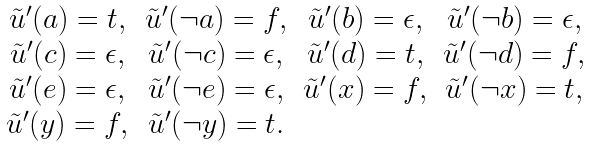Convert formula to latex. <formula><loc_0><loc_0><loc_500><loc_500>\begin{array} { c c c c } \tilde { u } ^ { \prime } ( a ) = t , & \tilde { u } ^ { \prime } ( \neg a ) = f , & \tilde { u } ^ { \prime } ( b ) = \epsilon , & \tilde { u } ^ { \prime } ( \neg b ) = \epsilon , \\ \tilde { u } ^ { \prime } ( c ) = \epsilon , & \tilde { u } ^ { \prime } ( \neg c ) = \epsilon , & \tilde { u } ^ { \prime } ( d ) = t , & \tilde { u } ^ { \prime } ( \neg d ) = f , \\ \tilde { u } ^ { \prime } ( e ) = \epsilon , & \tilde { u } ^ { \prime } ( \neg e ) = \epsilon , & \tilde { u } ^ { \prime } ( x ) = f , & \tilde { u } ^ { \prime } ( \neg x ) = t , \\ \tilde { u } ^ { \prime } ( y ) = f , & \tilde { u } ^ { \prime } ( \neg y ) = t . & & \\ \end{array}</formula> 